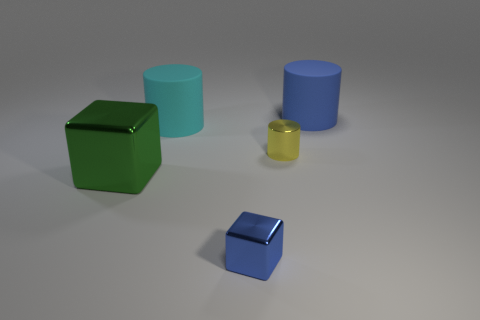What size is the matte cylinder that is the same color as the tiny shiny cube?
Keep it short and to the point. Large. What number of blocks are either purple matte objects or blue shiny things?
Offer a terse response. 1. There is a matte thing that is left of the tiny cube; is it the same shape as the tiny yellow thing?
Offer a terse response. Yes. Is the number of big cyan matte cylinders to the left of the big cyan cylinder greater than the number of small cylinders?
Your answer should be very brief. No. There is a shiny object that is the same size as the cyan cylinder; what is its color?
Your answer should be very brief. Green. How many objects are either large matte cylinders to the left of the small cylinder or tiny shiny objects?
Make the answer very short. 3. There is a big cylinder that is to the right of the tiny thing that is in front of the big green block; what is its material?
Keep it short and to the point. Rubber. Are there any large cyan things made of the same material as the large blue object?
Give a very brief answer. Yes. There is a small object behind the green object; is there a yellow cylinder that is in front of it?
Ensure brevity in your answer.  No. There is a blue object behind the yellow shiny cylinder; what material is it?
Give a very brief answer. Rubber. 